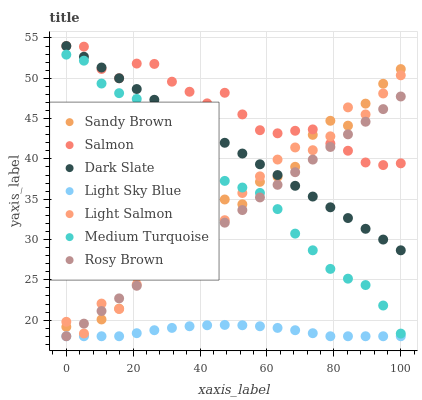Does Light Sky Blue have the minimum area under the curve?
Answer yes or no. Yes. Does Salmon have the maximum area under the curve?
Answer yes or no. Yes. Does Rosy Brown have the minimum area under the curve?
Answer yes or no. No. Does Rosy Brown have the maximum area under the curve?
Answer yes or no. No. Is Rosy Brown the smoothest?
Answer yes or no. Yes. Is Light Salmon the roughest?
Answer yes or no. Yes. Is Salmon the smoothest?
Answer yes or no. No. Is Salmon the roughest?
Answer yes or no. No. Does Rosy Brown have the lowest value?
Answer yes or no. Yes. Does Salmon have the lowest value?
Answer yes or no. No. Does Dark Slate have the highest value?
Answer yes or no. Yes. Does Rosy Brown have the highest value?
Answer yes or no. No. Is Medium Turquoise less than Salmon?
Answer yes or no. Yes. Is Sandy Brown greater than Light Sky Blue?
Answer yes or no. Yes. Does Rosy Brown intersect Dark Slate?
Answer yes or no. Yes. Is Rosy Brown less than Dark Slate?
Answer yes or no. No. Is Rosy Brown greater than Dark Slate?
Answer yes or no. No. Does Medium Turquoise intersect Salmon?
Answer yes or no. No. 